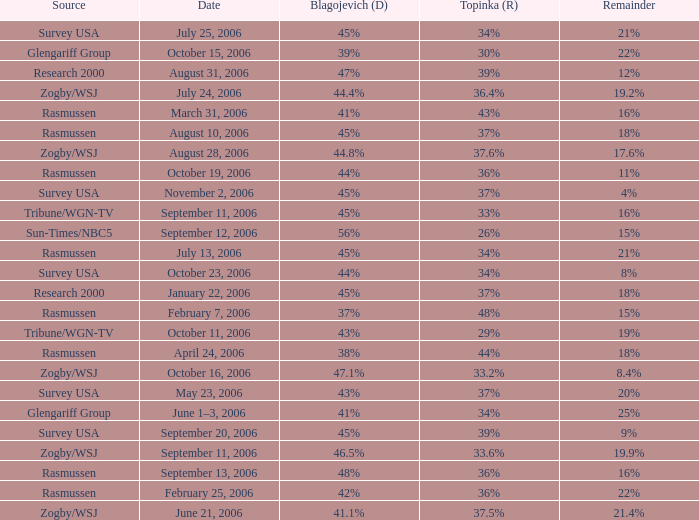Help me parse the entirety of this table. {'header': ['Source', 'Date', 'Blagojevich (D)', 'Topinka (R)', 'Remainder'], 'rows': [['Survey USA', 'July 25, 2006', '45%', '34%', '21%'], ['Glengariff Group', 'October 15, 2006', '39%', '30%', '22%'], ['Research 2000', 'August 31, 2006', '47%', '39%', '12%'], ['Zogby/WSJ', 'July 24, 2006', '44.4%', '36.4%', '19.2%'], ['Rasmussen', 'March 31, 2006', '41%', '43%', '16%'], ['Rasmussen', 'August 10, 2006', '45%', '37%', '18%'], ['Zogby/WSJ', 'August 28, 2006', '44.8%', '37.6%', '17.6%'], ['Rasmussen', 'October 19, 2006', '44%', '36%', '11%'], ['Survey USA', 'November 2, 2006', '45%', '37%', '4%'], ['Tribune/WGN-TV', 'September 11, 2006', '45%', '33%', '16%'], ['Sun-Times/NBC5', 'September 12, 2006', '56%', '26%', '15%'], ['Rasmussen', 'July 13, 2006', '45%', '34%', '21%'], ['Survey USA', 'October 23, 2006', '44%', '34%', '8%'], ['Research 2000', 'January 22, 2006', '45%', '37%', '18%'], ['Rasmussen', 'February 7, 2006', '37%', '48%', '15%'], ['Tribune/WGN-TV', 'October 11, 2006', '43%', '29%', '19%'], ['Rasmussen', 'April 24, 2006', '38%', '44%', '18%'], ['Zogby/WSJ', 'October 16, 2006', '47.1%', '33.2%', '8.4%'], ['Survey USA', 'May 23, 2006', '43%', '37%', '20%'], ['Glengariff Group', 'June 1–3, 2006', '41%', '34%', '25%'], ['Survey USA', 'September 20, 2006', '45%', '39%', '9%'], ['Zogby/WSJ', 'September 11, 2006', '46.5%', '33.6%', '19.9%'], ['Rasmussen', 'September 13, 2006', '48%', '36%', '16%'], ['Rasmussen', 'February 25, 2006', '42%', '36%', '22%'], ['Zogby/WSJ', 'June 21, 2006', '41.1%', '37.5%', '21.4%']]} Which blagojevich (d) has a zogby/wsj origin and an october 16, 2006 date? 47.1%. 